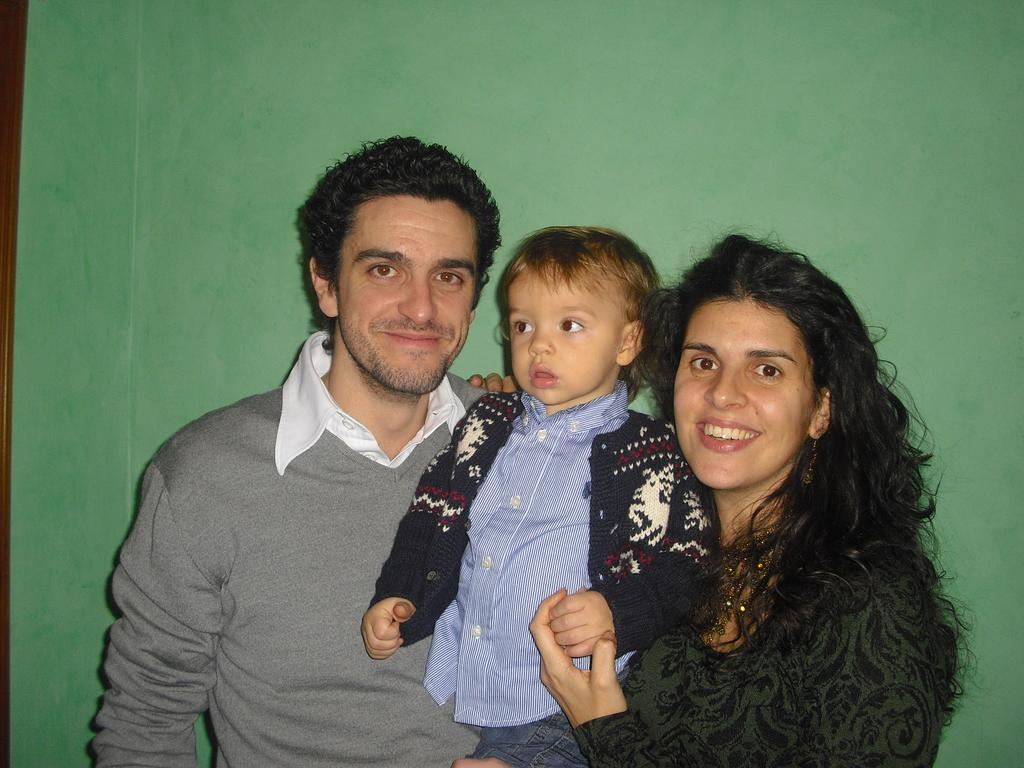How many people are in the image? There are three people in the image. What can be observed about the clothing of each person? Each person is wearing a different color dress. What color is the background of the image? The background of the image is green. Can you tell me what type of humor the squirrel in the image is known for? There is no squirrel present in the image, so it is not possible to determine its sense of humor. 